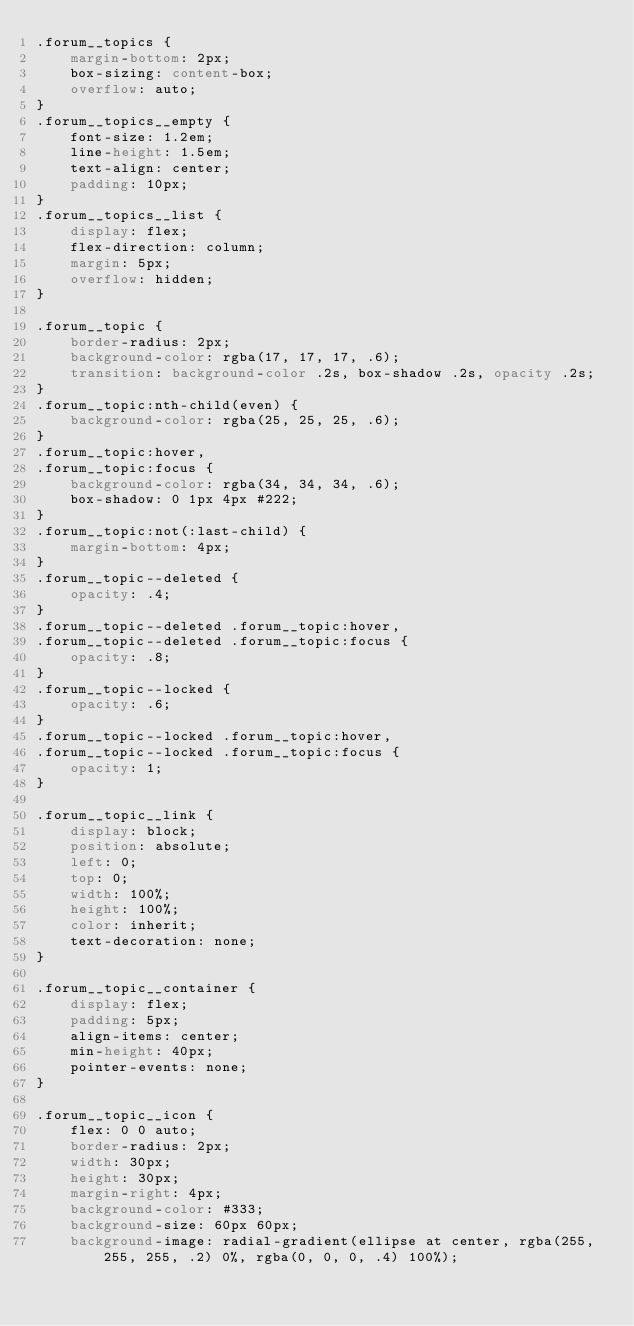<code> <loc_0><loc_0><loc_500><loc_500><_CSS_>.forum__topics {
    margin-bottom: 2px;
    box-sizing: content-box;
    overflow: auto;
}
.forum__topics__empty {
    font-size: 1.2em;
    line-height: 1.5em;
    text-align: center;
    padding: 10px;
}
.forum__topics__list {
    display: flex;
    flex-direction: column;
    margin: 5px;
    overflow: hidden;
}

.forum__topic {
    border-radius: 2px;
    background-color: rgba(17, 17, 17, .6);
    transition: background-color .2s, box-shadow .2s, opacity .2s;
}
.forum__topic:nth-child(even) {
    background-color: rgba(25, 25, 25, .6);
}
.forum__topic:hover,
.forum__topic:focus {
    background-color: rgba(34, 34, 34, .6);
    box-shadow: 0 1px 4px #222;
}
.forum__topic:not(:last-child) {
    margin-bottom: 4px;
}
.forum__topic--deleted {
    opacity: .4;
}
.forum__topic--deleted .forum__topic:hover,
.forum__topic--deleted .forum__topic:focus {
    opacity: .8;
}
.forum__topic--locked {
    opacity: .6;
}
.forum__topic--locked .forum__topic:hover,
.forum__topic--locked .forum__topic:focus {
    opacity: 1;
}

.forum__topic__link {
    display: block;
    position: absolute;
    left: 0;
    top: 0;
    width: 100%;
    height: 100%;
    color: inherit;
    text-decoration: none;
}

.forum__topic__container {
    display: flex;
    padding: 5px;
    align-items: center;
    min-height: 40px;
    pointer-events: none;
}

.forum__topic__icon {
    flex: 0 0 auto;
    border-radius: 2px;
    width: 30px;
    height: 30px;
    margin-right: 4px;
    background-color: #333;
    background-size: 60px 60px;
    background-image: radial-gradient(ellipse at center, rgba(255, 255, 255, .2) 0%, rgba(0, 0, 0, .4) 100%);</code> 